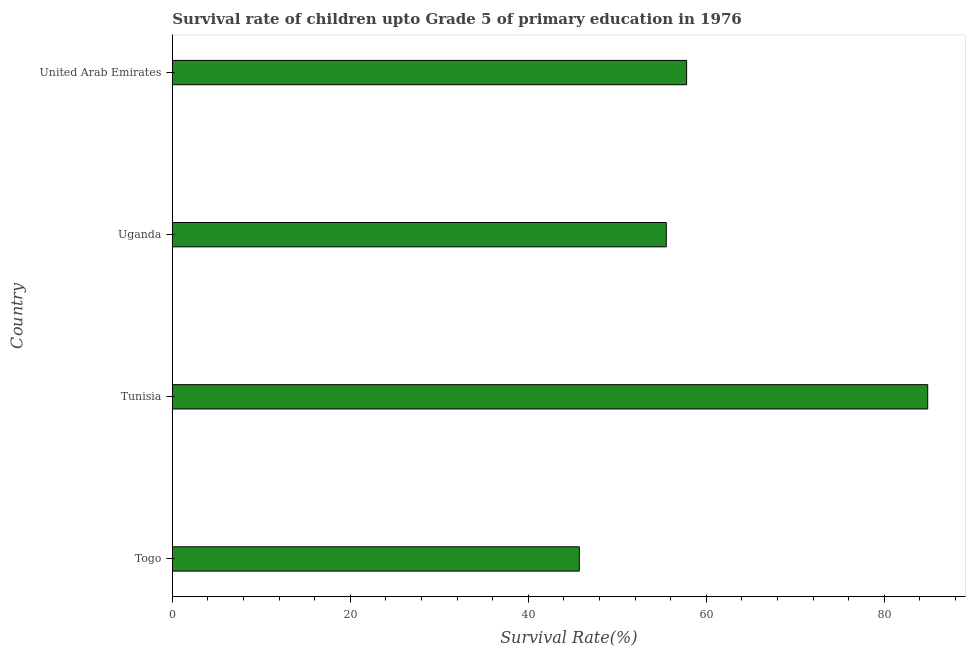Does the graph contain any zero values?
Offer a terse response. No. What is the title of the graph?
Your answer should be very brief. Survival rate of children upto Grade 5 of primary education in 1976 . What is the label or title of the X-axis?
Your response must be concise. Survival Rate(%). What is the label or title of the Y-axis?
Your response must be concise. Country. What is the survival rate in Uganda?
Your answer should be very brief. 55.5. Across all countries, what is the maximum survival rate?
Make the answer very short. 84.87. Across all countries, what is the minimum survival rate?
Provide a succinct answer. 45.73. In which country was the survival rate maximum?
Your answer should be very brief. Tunisia. In which country was the survival rate minimum?
Your answer should be very brief. Togo. What is the sum of the survival rate?
Ensure brevity in your answer.  243.88. What is the difference between the survival rate in Tunisia and Uganda?
Offer a very short reply. 29.38. What is the average survival rate per country?
Keep it short and to the point. 60.97. What is the median survival rate?
Ensure brevity in your answer.  56.64. What is the ratio of the survival rate in Togo to that in Uganda?
Ensure brevity in your answer.  0.82. Is the difference between the survival rate in Togo and Tunisia greater than the difference between any two countries?
Offer a terse response. Yes. What is the difference between the highest and the second highest survival rate?
Ensure brevity in your answer.  27.09. Is the sum of the survival rate in Tunisia and Uganda greater than the maximum survival rate across all countries?
Keep it short and to the point. Yes. What is the difference between the highest and the lowest survival rate?
Keep it short and to the point. 39.14. In how many countries, is the survival rate greater than the average survival rate taken over all countries?
Ensure brevity in your answer.  1. How many bars are there?
Keep it short and to the point. 4. Are the values on the major ticks of X-axis written in scientific E-notation?
Your response must be concise. No. What is the Survival Rate(%) in Togo?
Make the answer very short. 45.73. What is the Survival Rate(%) of Tunisia?
Your response must be concise. 84.87. What is the Survival Rate(%) in Uganda?
Keep it short and to the point. 55.5. What is the Survival Rate(%) of United Arab Emirates?
Ensure brevity in your answer.  57.78. What is the difference between the Survival Rate(%) in Togo and Tunisia?
Give a very brief answer. -39.14. What is the difference between the Survival Rate(%) in Togo and Uganda?
Offer a terse response. -9.77. What is the difference between the Survival Rate(%) in Togo and United Arab Emirates?
Your response must be concise. -12.05. What is the difference between the Survival Rate(%) in Tunisia and Uganda?
Make the answer very short. 29.38. What is the difference between the Survival Rate(%) in Tunisia and United Arab Emirates?
Offer a very short reply. 27.09. What is the difference between the Survival Rate(%) in Uganda and United Arab Emirates?
Your answer should be very brief. -2.29. What is the ratio of the Survival Rate(%) in Togo to that in Tunisia?
Provide a short and direct response. 0.54. What is the ratio of the Survival Rate(%) in Togo to that in Uganda?
Your answer should be very brief. 0.82. What is the ratio of the Survival Rate(%) in Togo to that in United Arab Emirates?
Provide a succinct answer. 0.79. What is the ratio of the Survival Rate(%) in Tunisia to that in Uganda?
Provide a succinct answer. 1.53. What is the ratio of the Survival Rate(%) in Tunisia to that in United Arab Emirates?
Provide a short and direct response. 1.47. What is the ratio of the Survival Rate(%) in Uganda to that in United Arab Emirates?
Give a very brief answer. 0.96. 